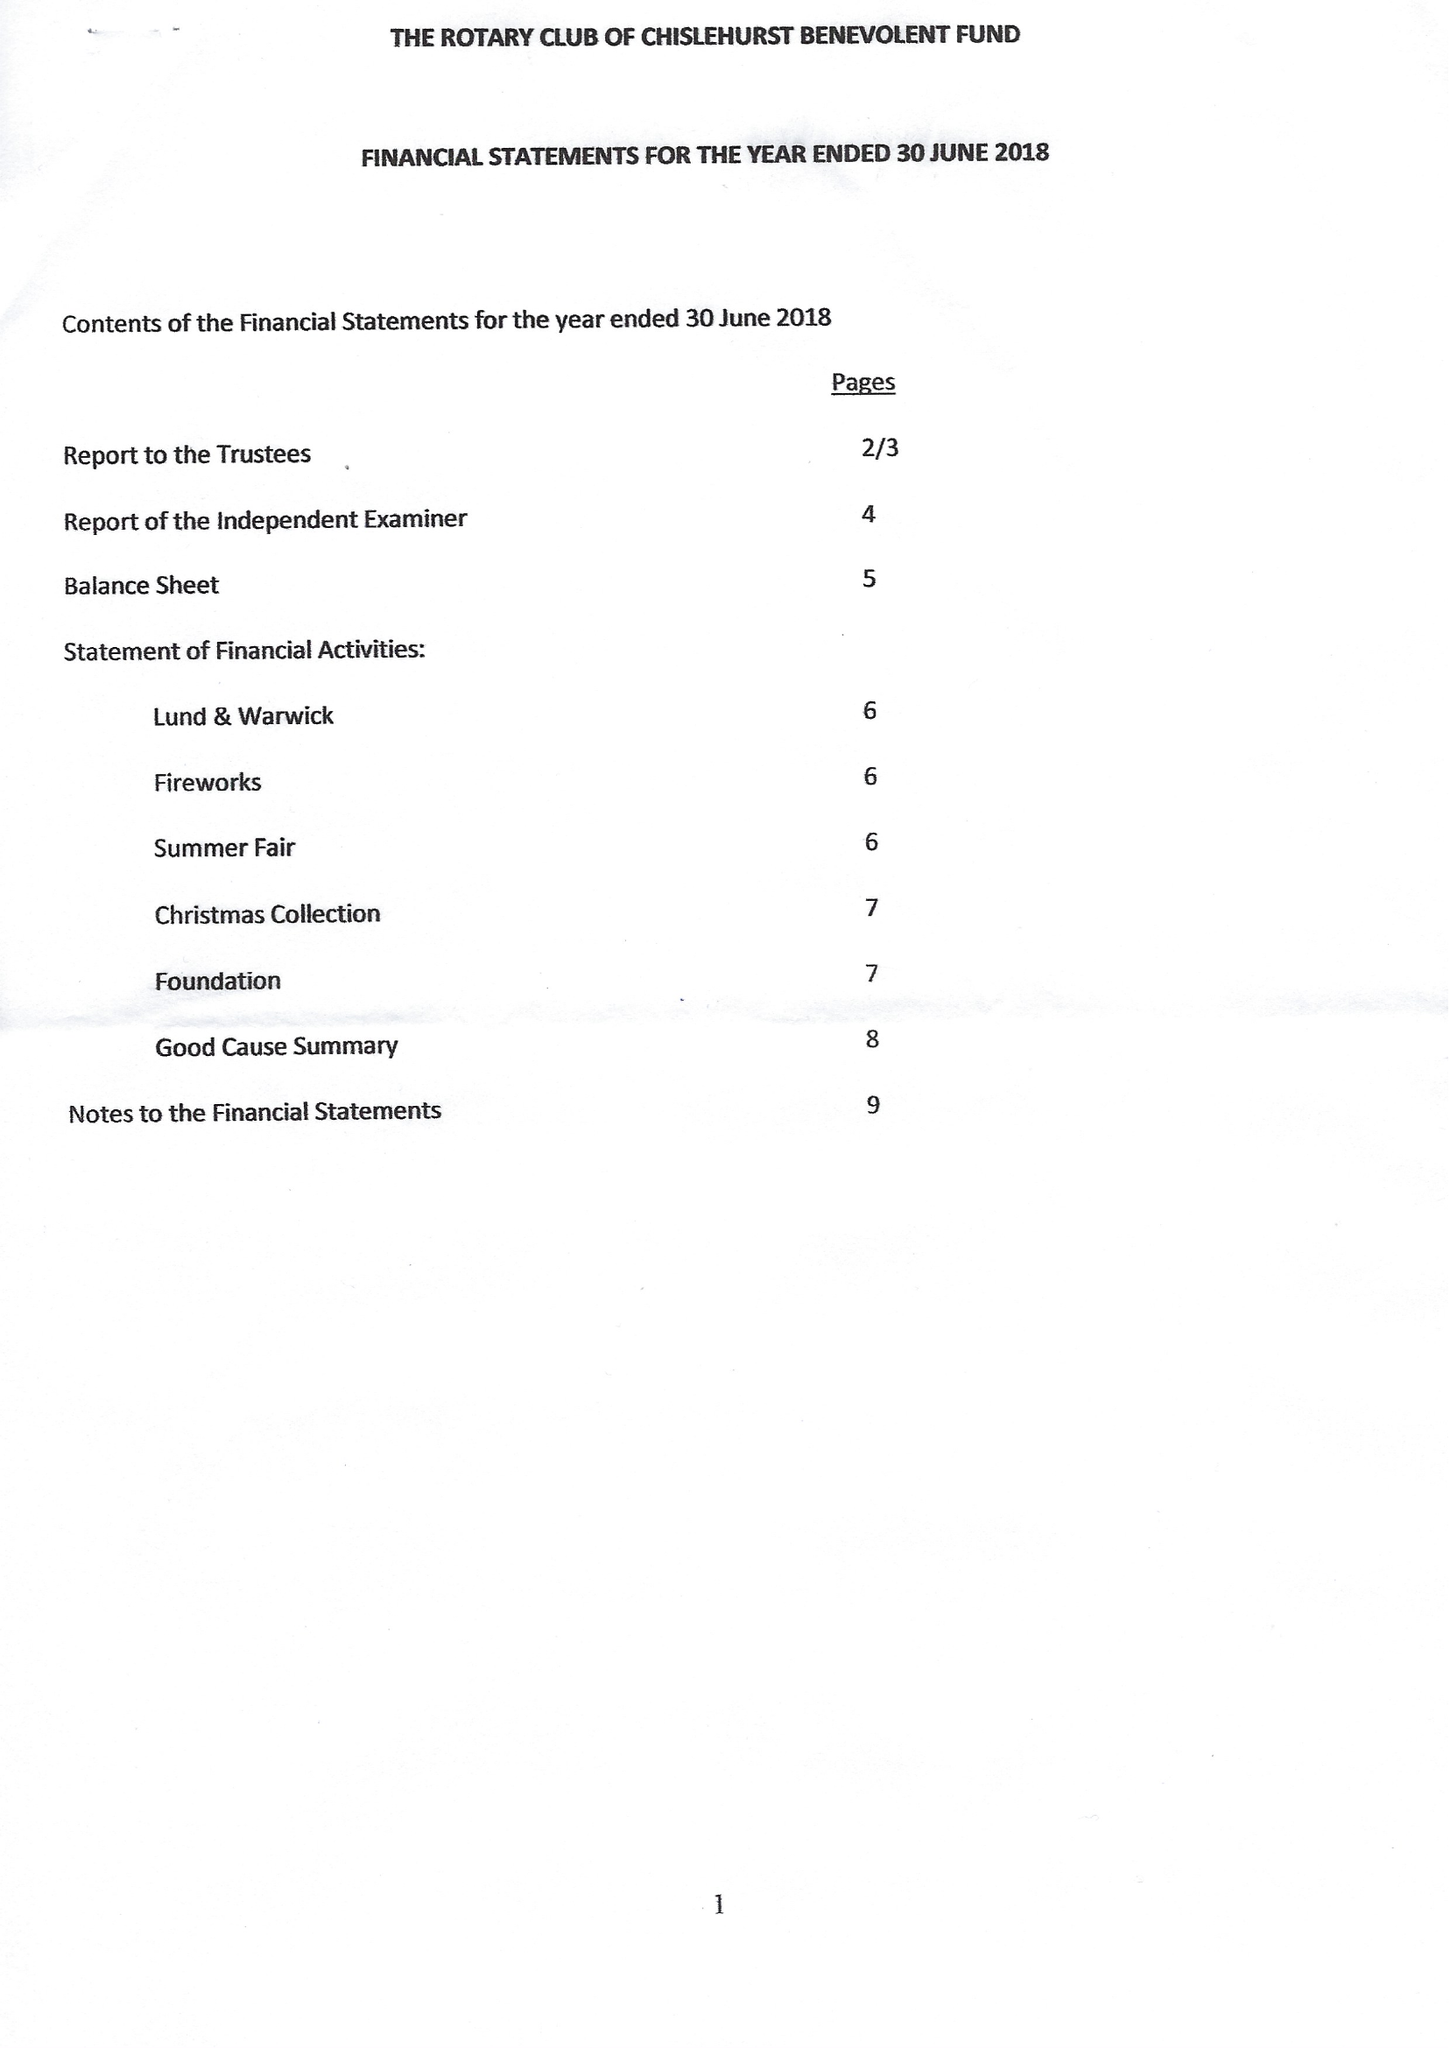What is the value for the address__post_town?
Answer the question using a single word or phrase. ORPINGTON 